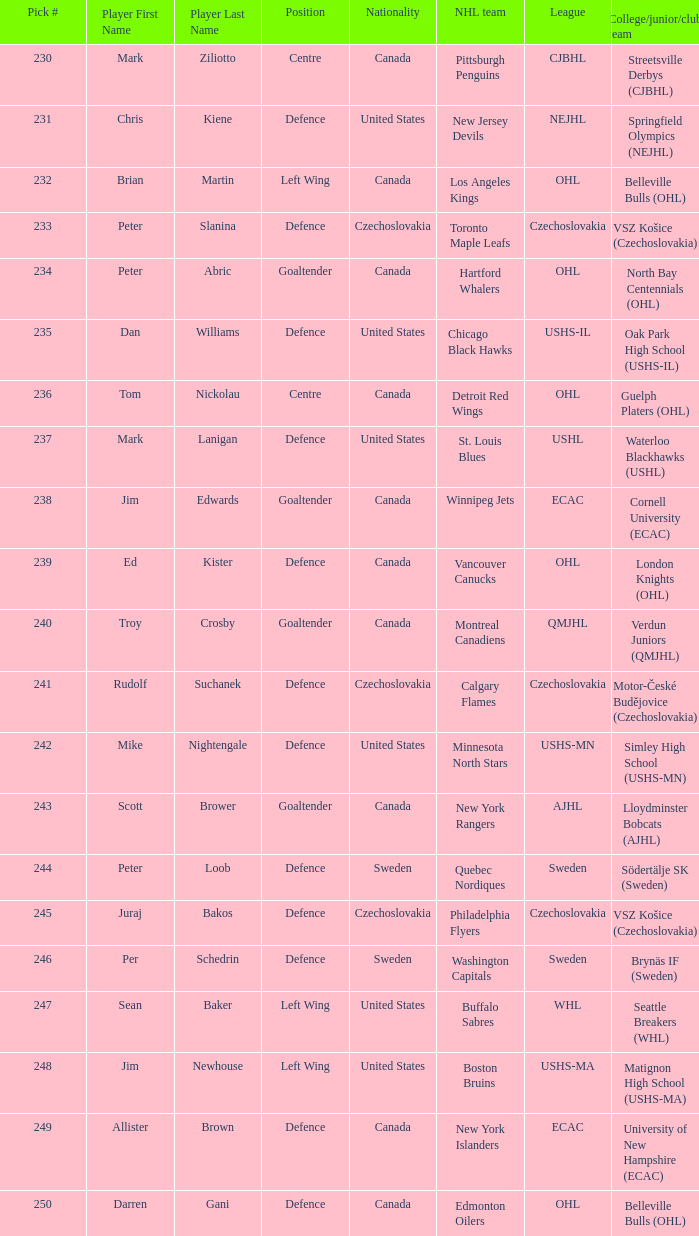What position does allister brown play. Defence. 